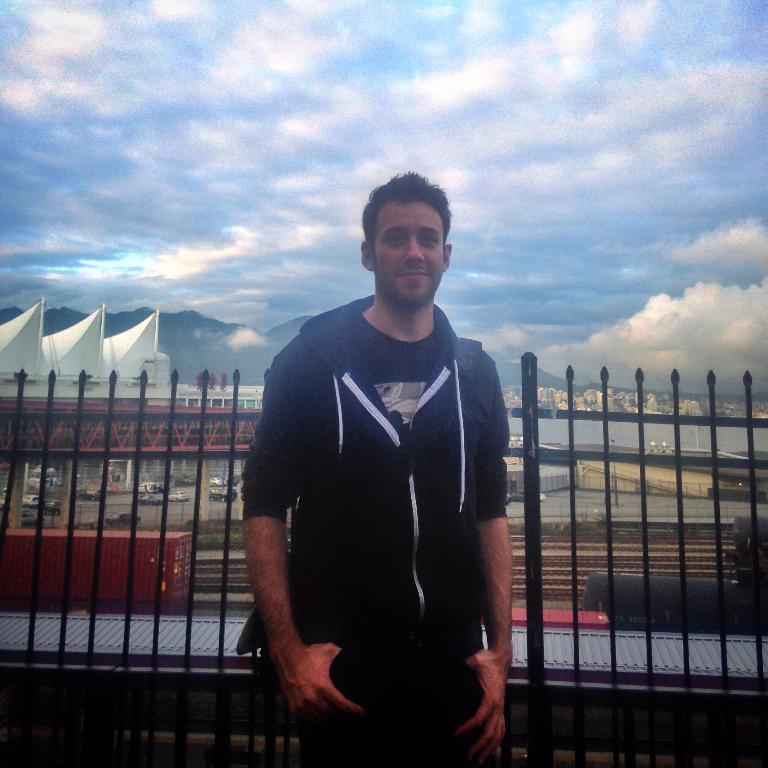Describe this image in one or two sentences. In this image there is a person standing. Behind him there is a fence. Left side of the image few vehicles are on the road. Right side there is a lake. Background there are few buildings. Behind there are few hills. Top of the image there is sky. 